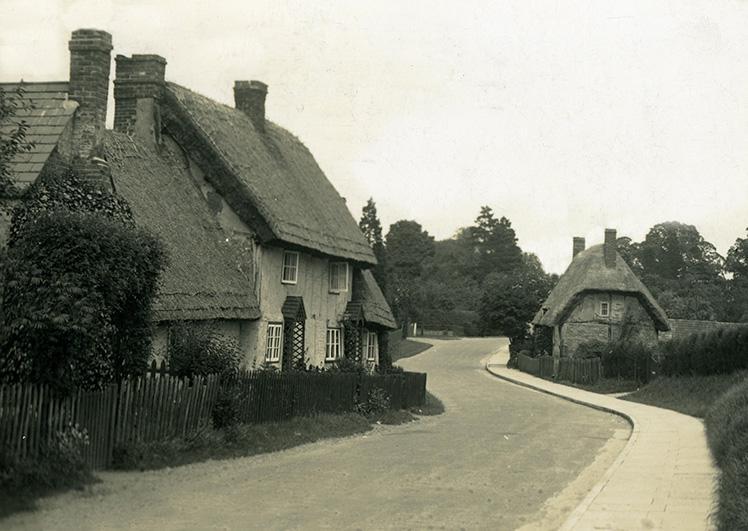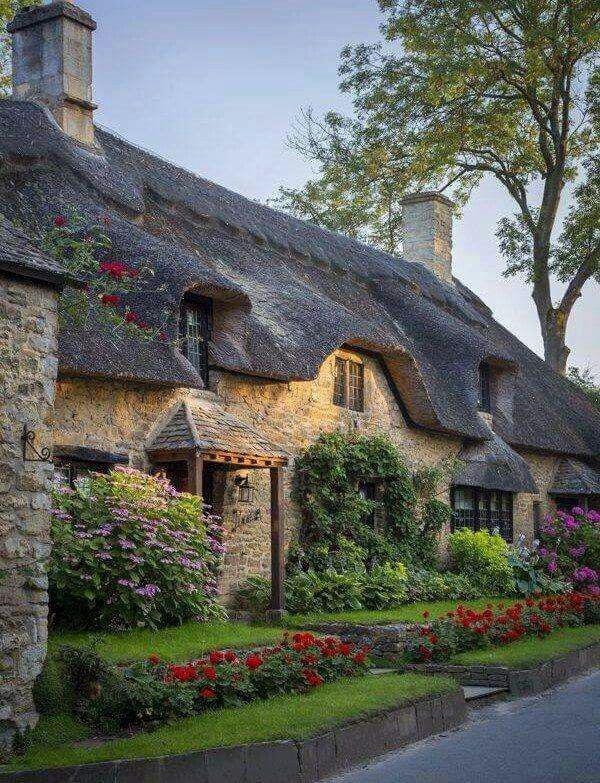The first image is the image on the left, the second image is the image on the right. Assess this claim about the two images: "A house with a landscaped lawn has a roof with at least three notches around windows on its front side facing the street.". Correct or not? Answer yes or no. Yes. The first image is the image on the left, the second image is the image on the right. Given the left and right images, does the statement "In at least one image there is a yellow bricked house facing forward right with two chimney." hold true? Answer yes or no. Yes. 